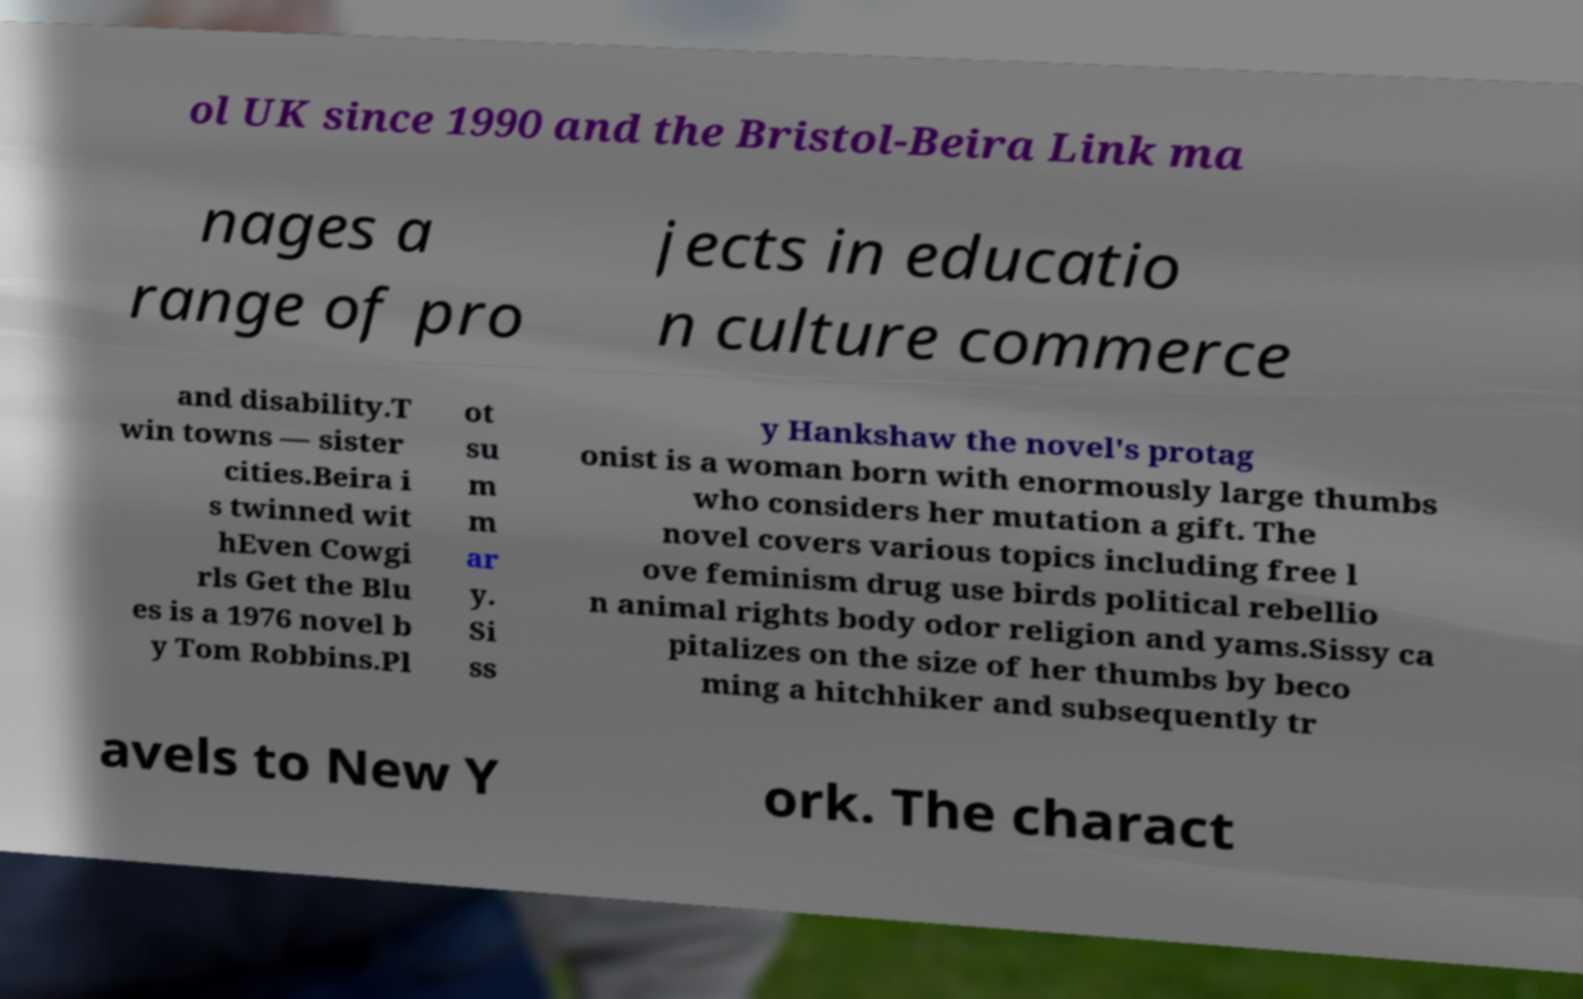Please read and relay the text visible in this image. What does it say? ol UK since 1990 and the Bristol-Beira Link ma nages a range of pro jects in educatio n culture commerce and disability.T win towns — sister cities.Beira i s twinned wit hEven Cowgi rls Get the Blu es is a 1976 novel b y Tom Robbins.Pl ot su m m ar y. Si ss y Hankshaw the novel's protag onist is a woman born with enormously large thumbs who considers her mutation a gift. The novel covers various topics including free l ove feminism drug use birds political rebellio n animal rights body odor religion and yams.Sissy ca pitalizes on the size of her thumbs by beco ming a hitchhiker and subsequently tr avels to New Y ork. The charact 